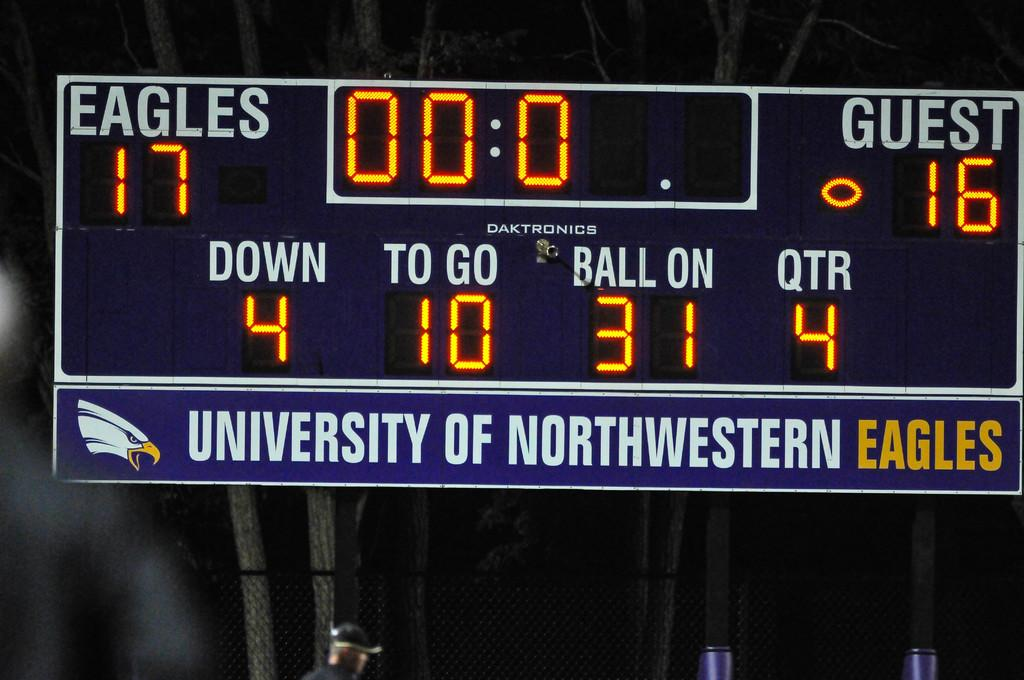<image>
Render a clear and concise summary of the photo. A University of Northwestern Eagles football score board shows a 4th quarter score of Eagles 17 to Guest 16. 